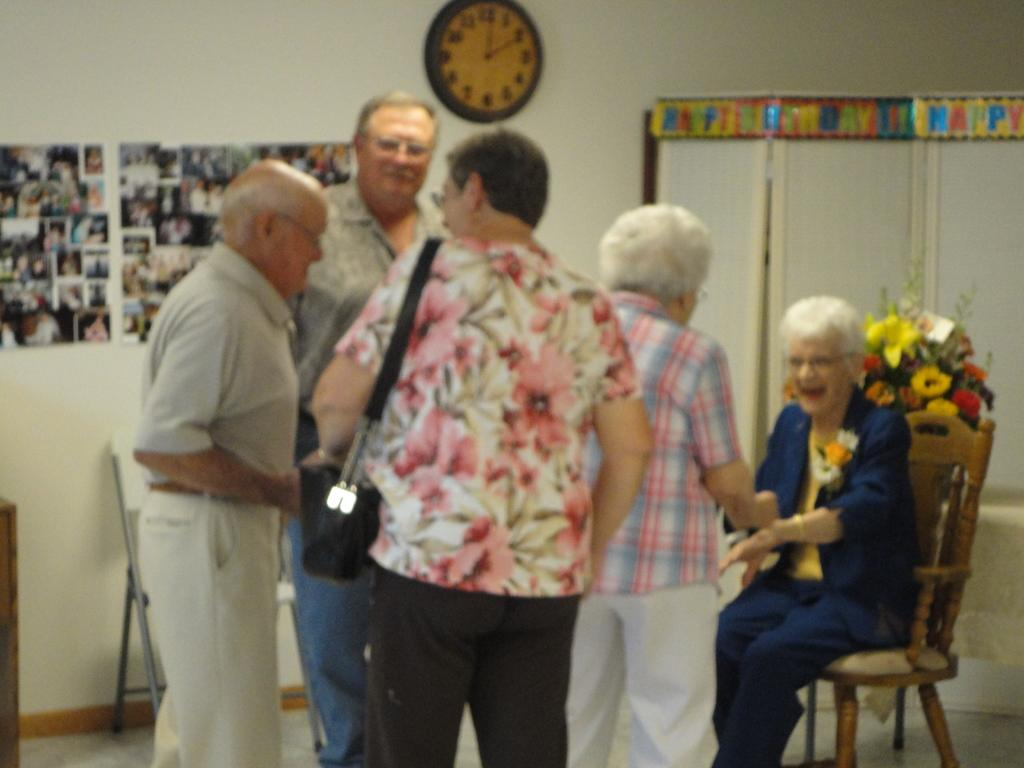<image>
Write a terse but informative summary of the picture. A happy birthday banner hangs over the windows in a group meeting room. 